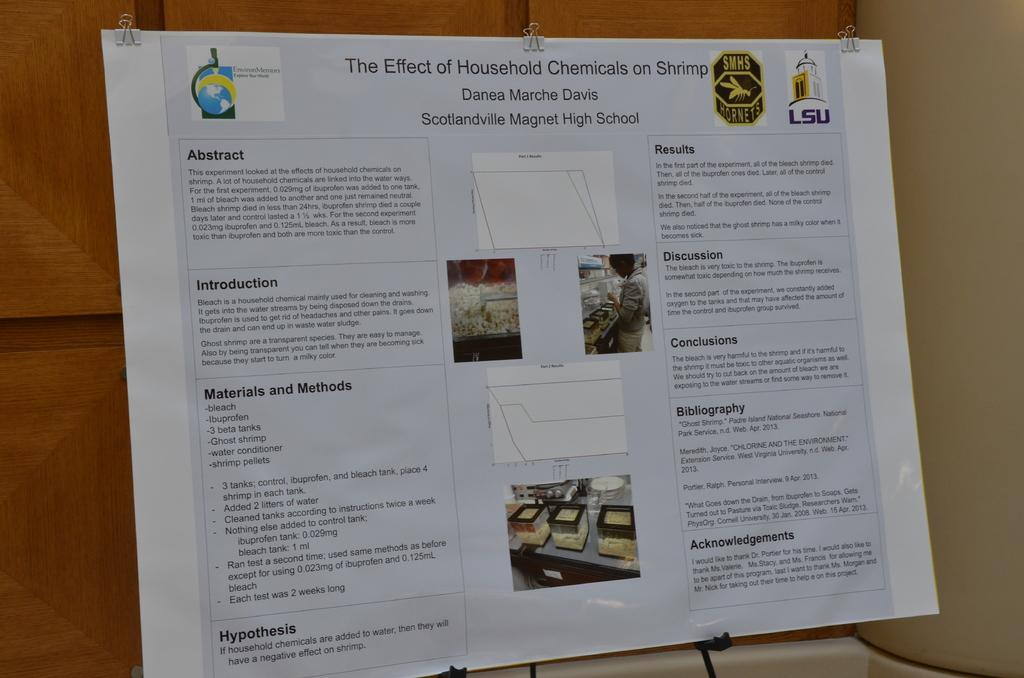Provide a one-sentence caption for the provided image. The science project is about the effect of household chemicals on shrimp. 